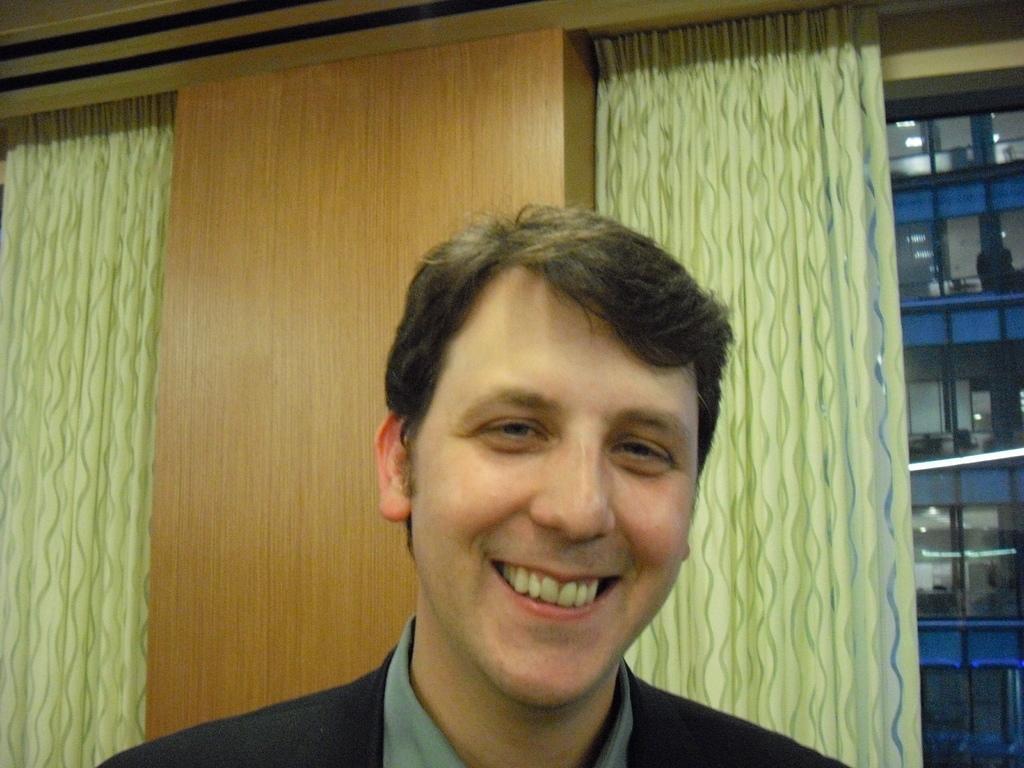Could you give a brief overview of what you see in this image? In this image I can see the person with black and grey color dress and the person is smiling. In the back I can see the curtains and the wooden wall. To the right there is a rack. 